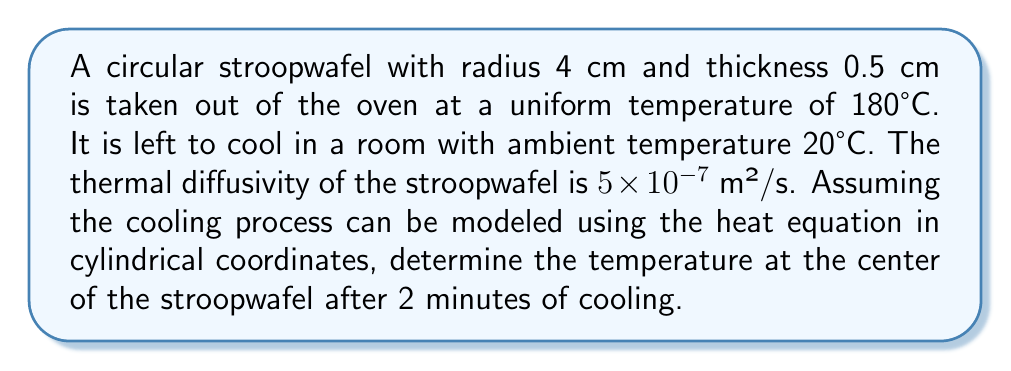Teach me how to tackle this problem. To solve this problem, we'll use the heat equation in cylindrical coordinates:

$$\frac{\partial T}{\partial t} = \alpha \left(\frac{\partial^2 T}{\partial r^2} + \frac{1}{r}\frac{\partial T}{\partial r} + \frac{\partial^2 T}{\partial z^2}\right)$$

Where $T$ is temperature, $t$ is time, $r$ is the radial coordinate, $z$ is the axial coordinate, and $\alpha$ is the thermal diffusivity.

Given the symmetry of the problem and the thin nature of the stroopwafel, we can simplify this to a one-dimensional radial problem:

$$\frac{\partial T}{\partial t} = \alpha \left(\frac{\partial^2 T}{\partial r^2} + \frac{1}{r}\frac{\partial T}{\partial r}\right)$$

The solution to this equation for a circular disk with initial uniform temperature $T_0$ and surface temperature $T_s$ is:

$$T(r,t) = T_s + (T_0 - T_s)\sum_{n=1}^{\infty}\frac{2}{a\alpha_n J_1(a\alpha_n)}J_0(r\alpha_n)e^{-\alpha \alpha_n^2 t}$$

Where $J_0$ and $J_1$ are Bessel functions of the first kind, $a$ is the radius, and $\alpha_n$ are the positive roots of $J_0(a\alpha_n) = 0$.

At the center of the stroopwafel, $r = 0$, and $J_0(0) = 1$, so:

$$T(0,t) = T_s + (T_0 - T_s)\sum_{n=1}^{\infty}\frac{2}{a\alpha_n J_1(a\alpha_n)}e^{-\alpha \alpha_n^2 t}$$

Given:
- $T_0 = 180°C$
- $T_s = 20°C$
- $a = 0.04$ m
- $\alpha = 5 \times 10^{-7}$ m²/s
- $t = 120$ s

Using the first few terms of the series and calculating the roots $\alpha_n$, we can approximate the temperature at the center after 2 minutes.
Answer: $T(0, 120) \approx 152°C$ 